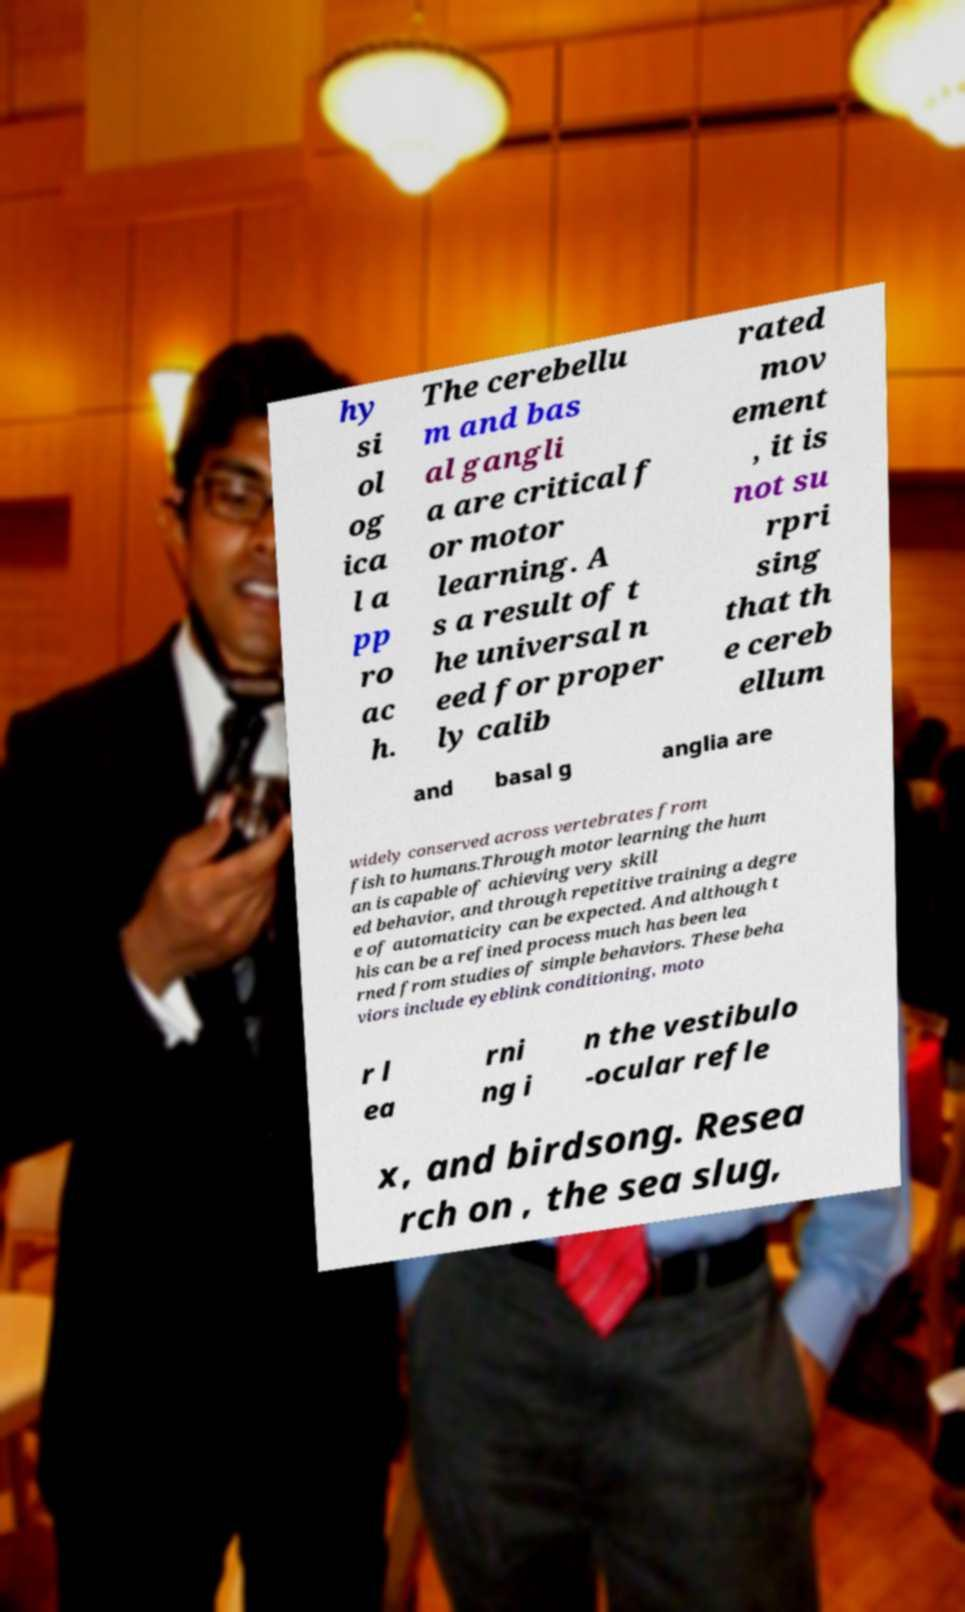Can you read and provide the text displayed in the image?This photo seems to have some interesting text. Can you extract and type it out for me? hy si ol og ica l a pp ro ac h. The cerebellu m and bas al gangli a are critical f or motor learning. A s a result of t he universal n eed for proper ly calib rated mov ement , it is not su rpri sing that th e cereb ellum and basal g anglia are widely conserved across vertebrates from fish to humans.Through motor learning the hum an is capable of achieving very skill ed behavior, and through repetitive training a degre e of automaticity can be expected. And although t his can be a refined process much has been lea rned from studies of simple behaviors. These beha viors include eyeblink conditioning, moto r l ea rni ng i n the vestibulo -ocular refle x, and birdsong. Resea rch on , the sea slug, 